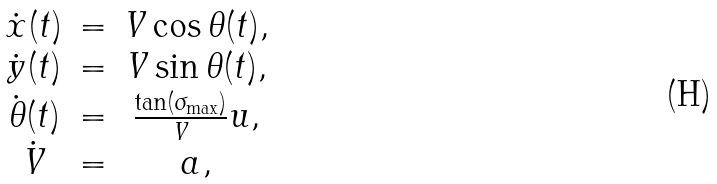Convert formula to latex. <formula><loc_0><loc_0><loc_500><loc_500>\begin{array} { c c c } \dot { x } ( t ) & = & V \cos \theta ( t ) , \\ \dot { y } ( t ) & = & V \sin \theta ( t ) , \\ \dot { \theta } ( t ) & = & \frac { \tan ( \sigma _ { \max } ) } { V } u , \\ \dot { V } & = & a , \end{array}</formula> 